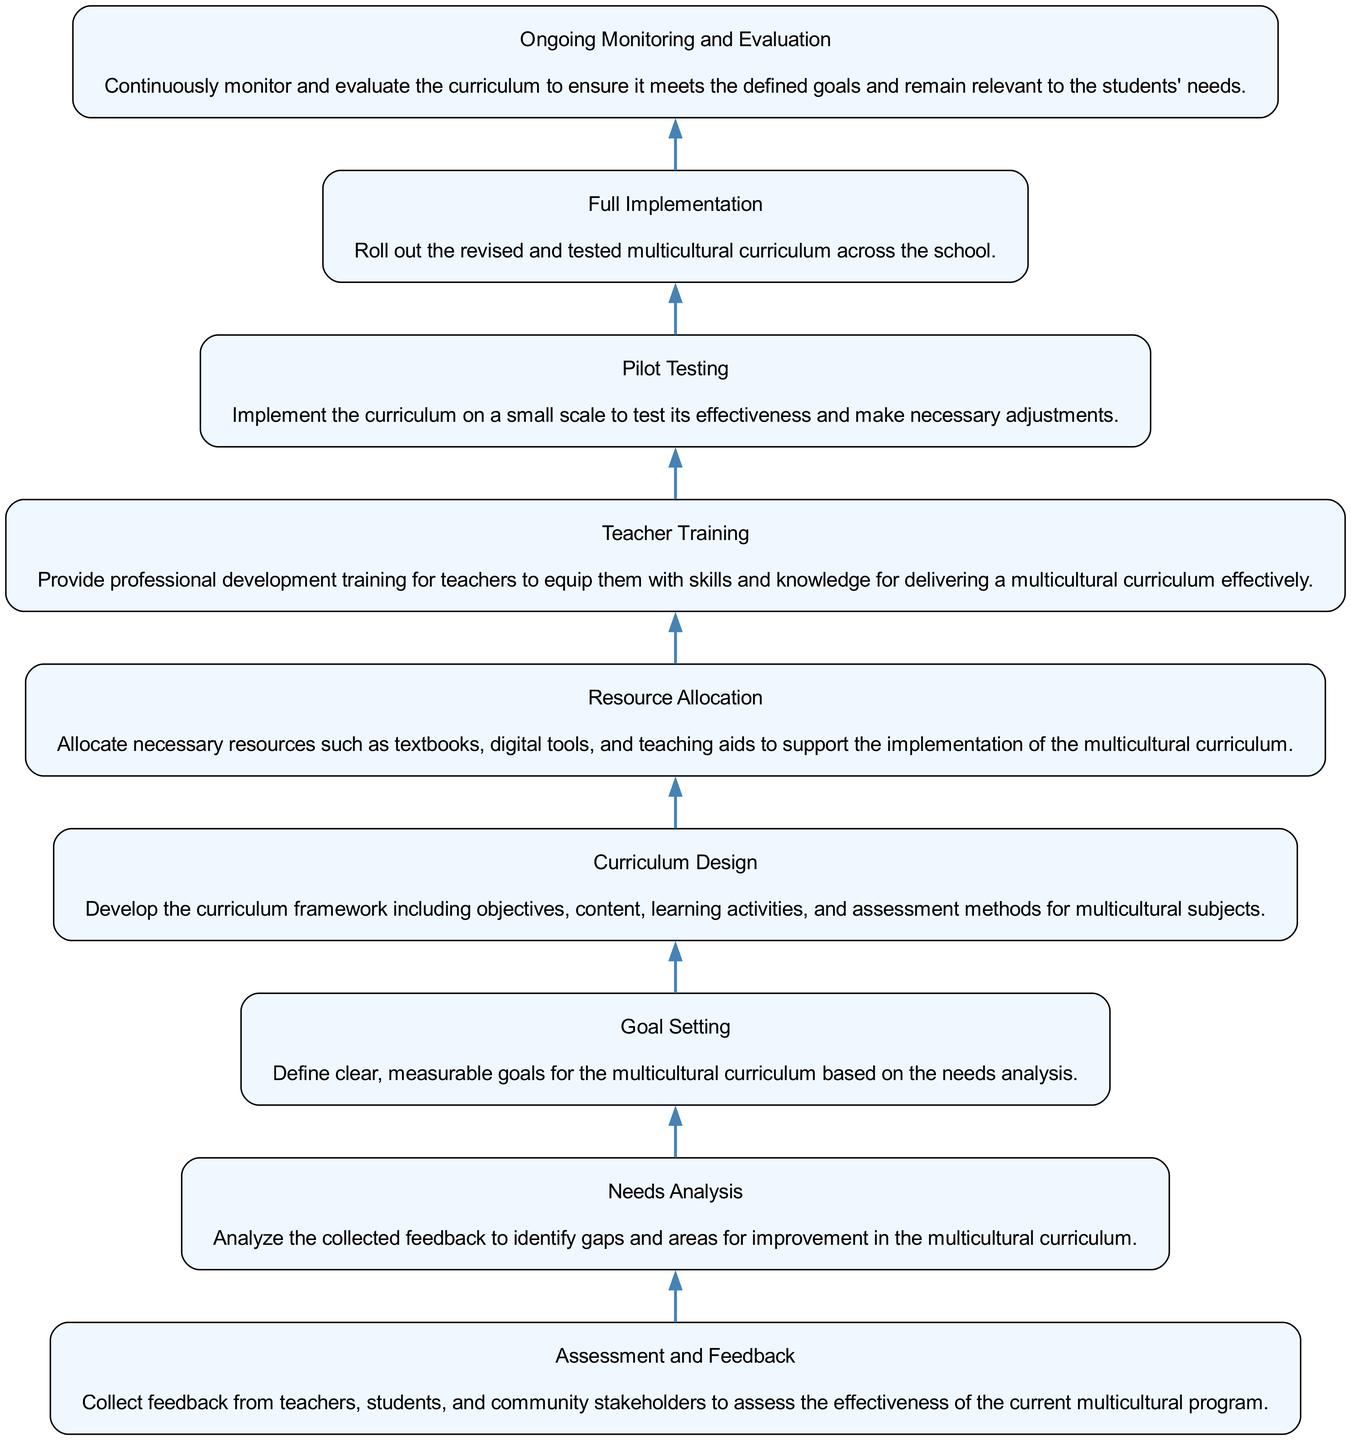What is the first step in the curriculum development workflow? The first step listed in the diagram is "Assessment and Feedback," as it is the starting point of the workflow process.
Answer: Assessment and Feedback What is the last step in the curriculum development workflow? The last step in the diagram is "Ongoing Monitoring and Evaluation," which indicates the continuous nature of the curriculum assessment.
Answer: Ongoing Monitoring and Evaluation How many total steps are there in the workflow? By counting the nodes in the diagram, there are a total of nine distinct steps from "Assessment and Feedback" to "Ongoing Monitoring and Evaluation."
Answer: 9 Which step follows "Teacher Training"? From the diagram, "Pilot Testing" directly follows "Teacher Training," indicating it is the subsequent phase in the workflow.
Answer: Pilot Testing What are the two main actions in the "Curriculum Design" step? The "Curriculum Design" step involves developing a curriculum framework that includes objectives, content, learning activities, and assessment methods, which are the primary actions undertaken during this step.
Answer: Develop curriculum framework What is the connection between "Needs Analysis" and "Goal Setting"? "Needs Analysis" connects to "Goal Setting" as it provides the analysis necessary to define clear, measurable goals based on identified gaps in the multicultural curriculum.
Answer: Analysis to goals Which step requires professional development training for teachers? The step titled "Teacher Training" explicitly states that it involves providing professional development training for teachers, making it clear that this is the focus at this stage.
Answer: Teacher Training What is the purpose of "Pilot Testing" in the workflow? The purpose of "Pilot Testing" is to implement the curriculum on a small scale to test its effectiveness, allowing for necessary adjustments before full implementation.
Answer: Test effectiveness How are resources allocated according to the diagram? In the "Resource Allocation" step, necessary resources such as textbooks and teaching aids are allocated to support the implementation of the multicultural curriculum.
Answer: Allocate resources What step comes before "Full Implementation"? The step that comes just before "Full Implementation" is "Pilot Testing," which is crucial for making adjustments before the full roll-out.
Answer: Pilot Testing 